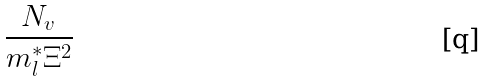Convert formula to latex. <formula><loc_0><loc_0><loc_500><loc_500>\frac { N _ { v } } { m _ { l } ^ { * } \Xi ^ { 2 } }</formula> 